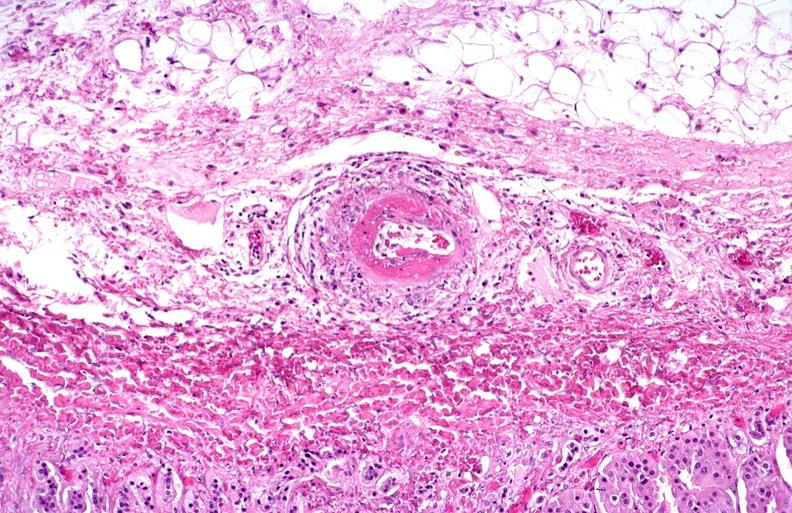s cardiovascular present?
Answer the question using a single word or phrase. Yes 